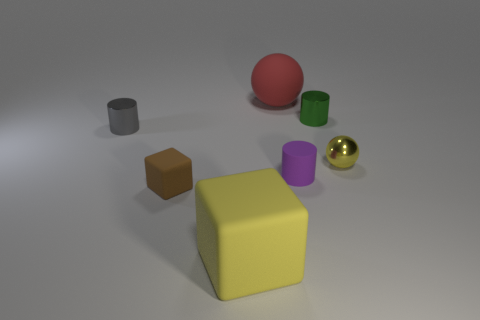There is a rubber thing that is the same color as the small shiny sphere; what shape is it?
Provide a succinct answer. Cube. There is a cylinder that is behind the small sphere and right of the brown object; what material is it?
Keep it short and to the point. Metal. Are there any other objects of the same size as the yellow matte thing?
Give a very brief answer. Yes. What is the size of the cube that is behind the big yellow cube?
Ensure brevity in your answer.  Small. The tiny cylinder that is in front of the ball in front of the big object that is behind the yellow matte block is what color?
Ensure brevity in your answer.  Purple. What is the color of the ball that is behind the metallic cylinder right of the gray thing?
Keep it short and to the point. Red. Is the number of green cylinders to the left of the small purple rubber cylinder greater than the number of big things that are in front of the yellow matte cube?
Provide a short and direct response. No. Do the yellow thing to the left of the yellow sphere and the ball on the right side of the large red rubber ball have the same material?
Your answer should be very brief. No. Are there any tiny purple objects to the right of the green cylinder?
Your response must be concise. No. What number of purple things are metallic balls or tiny objects?
Give a very brief answer. 1. 